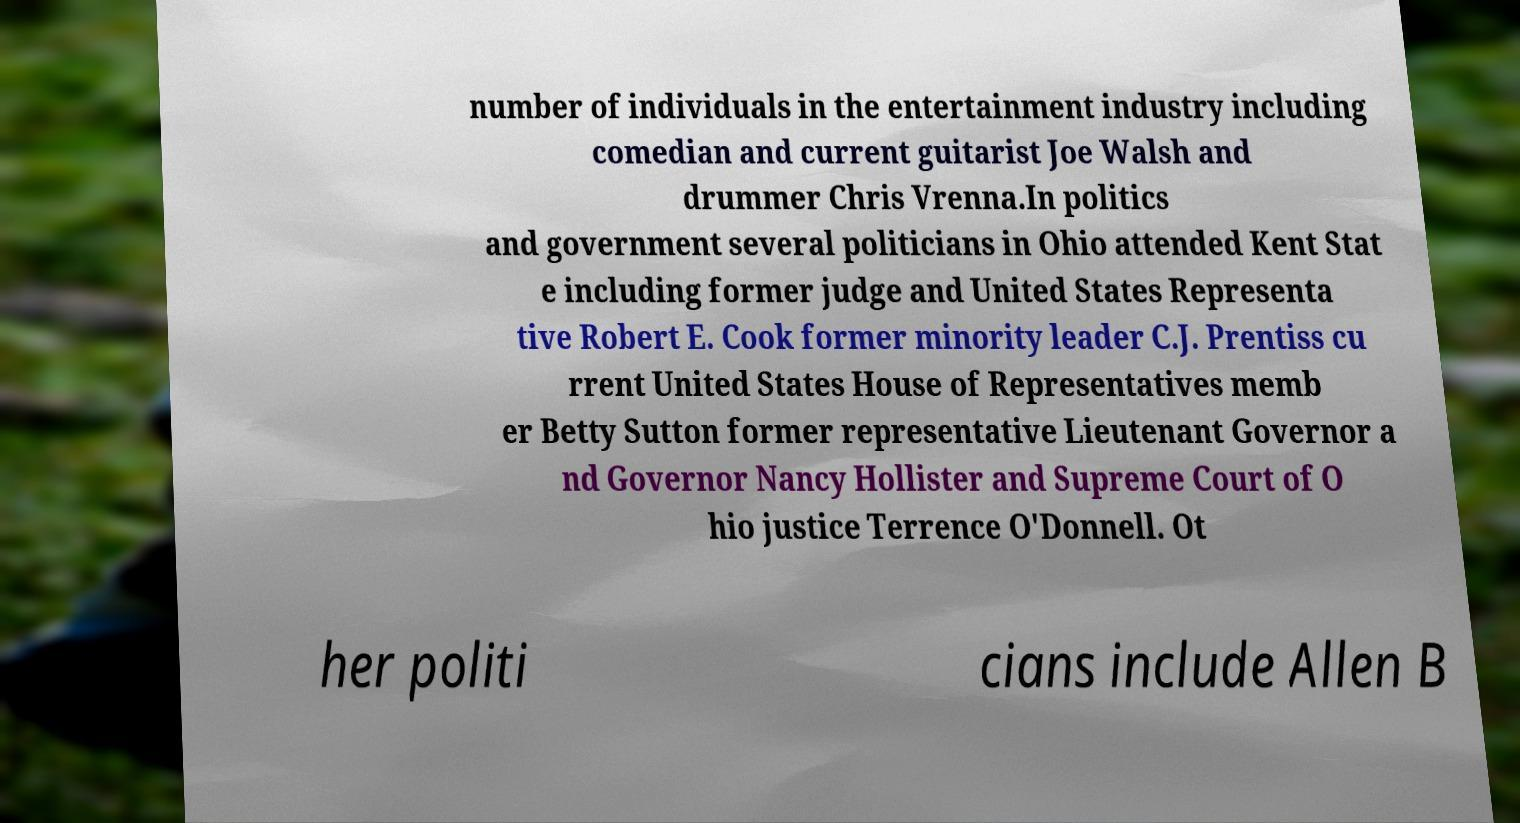Please identify and transcribe the text found in this image. number of individuals in the entertainment industry including comedian and current guitarist Joe Walsh and drummer Chris Vrenna.In politics and government several politicians in Ohio attended Kent Stat e including former judge and United States Representa tive Robert E. Cook former minority leader C.J. Prentiss cu rrent United States House of Representatives memb er Betty Sutton former representative Lieutenant Governor a nd Governor Nancy Hollister and Supreme Court of O hio justice Terrence O'Donnell. Ot her politi cians include Allen B 